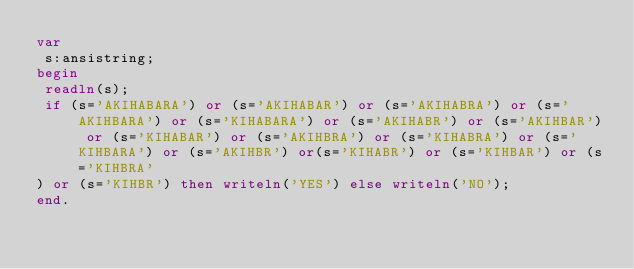<code> <loc_0><loc_0><loc_500><loc_500><_Pascal_>var
 s:ansistring;
begin
 readln(s);
 if (s='AKIHABARA') or (s='AKIHABAR') or (s='AKIHABRA') or (s='AKIHBARA') or (s='KIHABARA') or (s='AKIHABR') or (s='AKIHBAR') or (s='KIHABAR') or (s='AKIHBRA') or (s='KIHABRA') or (s='KIHBARA') or (s='AKIHBR') or(s='KIHABR') or (s='KIHBAR') or (s='KIHBRA'
) or (s='KIHBR') then writeln('YES') else writeln('NO');
end.</code> 